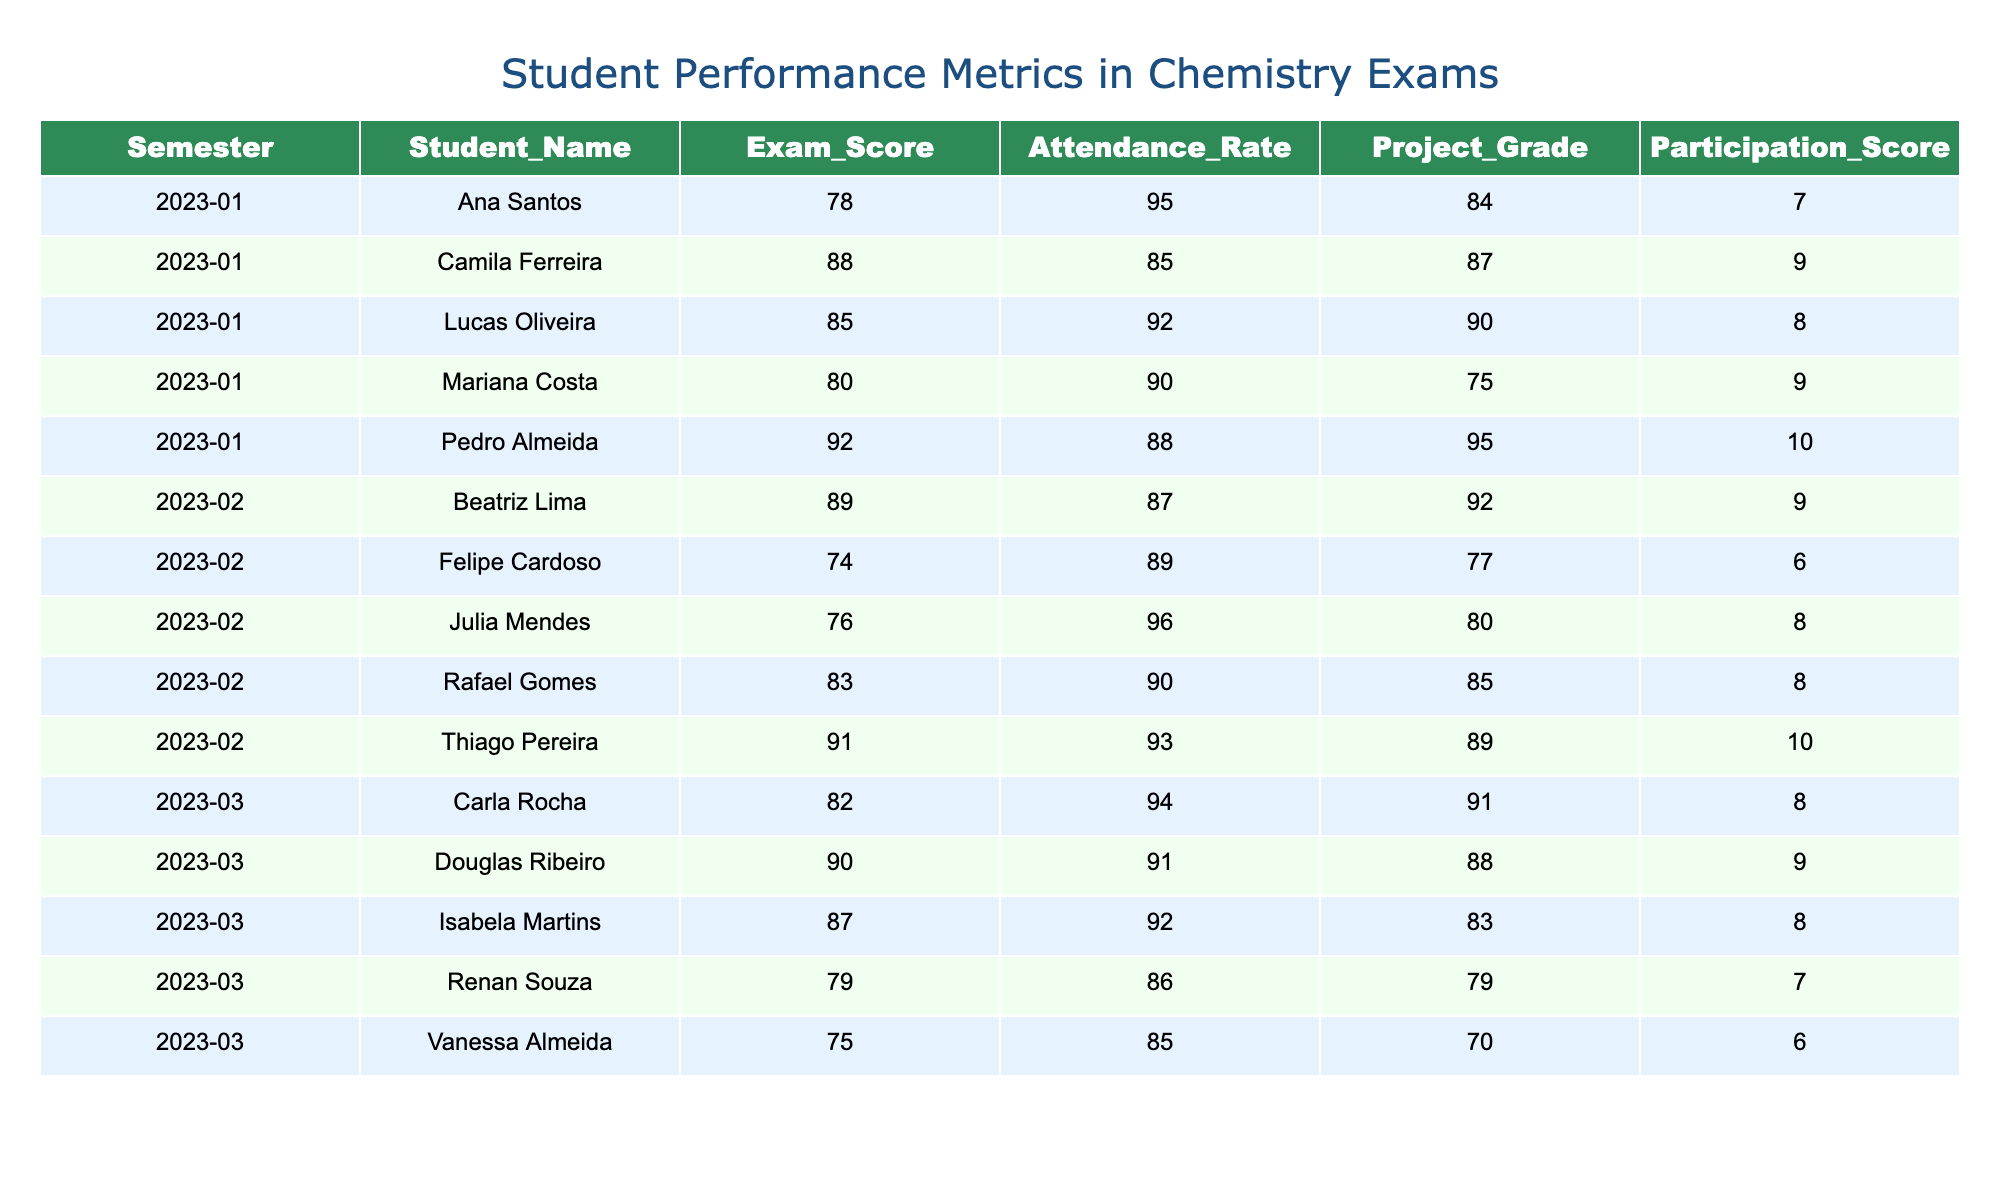What's the highest exam score achieved in the table? The highest exam score in the table is 92, which belongs to Pedro Almeida in semester 2023-1.
Answer: 92 What is the average attendance rate across all semesters? To find the average attendance rate, we sum all attendance rates (92 + 95 + 88 + 90 + 85 + 93 + 96 + 90 + 87 + 89 + 94 + 91 + 92 + 86 + 85) which is 1320, then divide by the number of students (15). So, 1320/15 = 88.
Answer: 88 Is there a student who consistently scored above 85 in all three semesters? By examining the scores from each semester, only Thiago Pereira from 2023-2 scored above 85 (91), but he did not have a record in other semesters. Therefore, the answer is no.
Answer: No What is the project grade of the student with the highest participation score? The student with the highest participation score is Pedro Almeida with a score of 10. His project grade is 95.
Answer: 95 What is the difference in exam scores between the best and worst-performing students in 2023-1? The best exam score in 2023-1 is 92 (Pedro Almeida) and the worst is 78 (Ana Santos). The difference is calculated as 92 - 78 = 14.
Answer: 14 How many students had an attendance rate below 90 in semester 2023-2? In semester 2023-2, the attendance rates are 93, 96, 90, 87, and 89. Only Felipe Cardoso had an attendance rate below 90. Thus, there is 1 student.
Answer: 1 What is the average project grade for students in semester 2023-3? The project grades for semester 2023-3 are 91, 88, 83, 79, and 70. Adding them gives 411, and dividing by the number of students (5) results in 411/5 = 82.2.
Answer: 82.2 Is Camila Ferreira's exam score higher than her project grade in 2023-1? Camila Ferreira's exam score is 88 and her project grade is 87. Since 88 is greater than 87, the answer is yes.
Answer: Yes What student had the highest attendance rate in semester 2023-1? Analyzing the attendance rates, Ana Santos has the highest attendance rate of 95 in semester 2023-1.
Answer: Ana Santos 